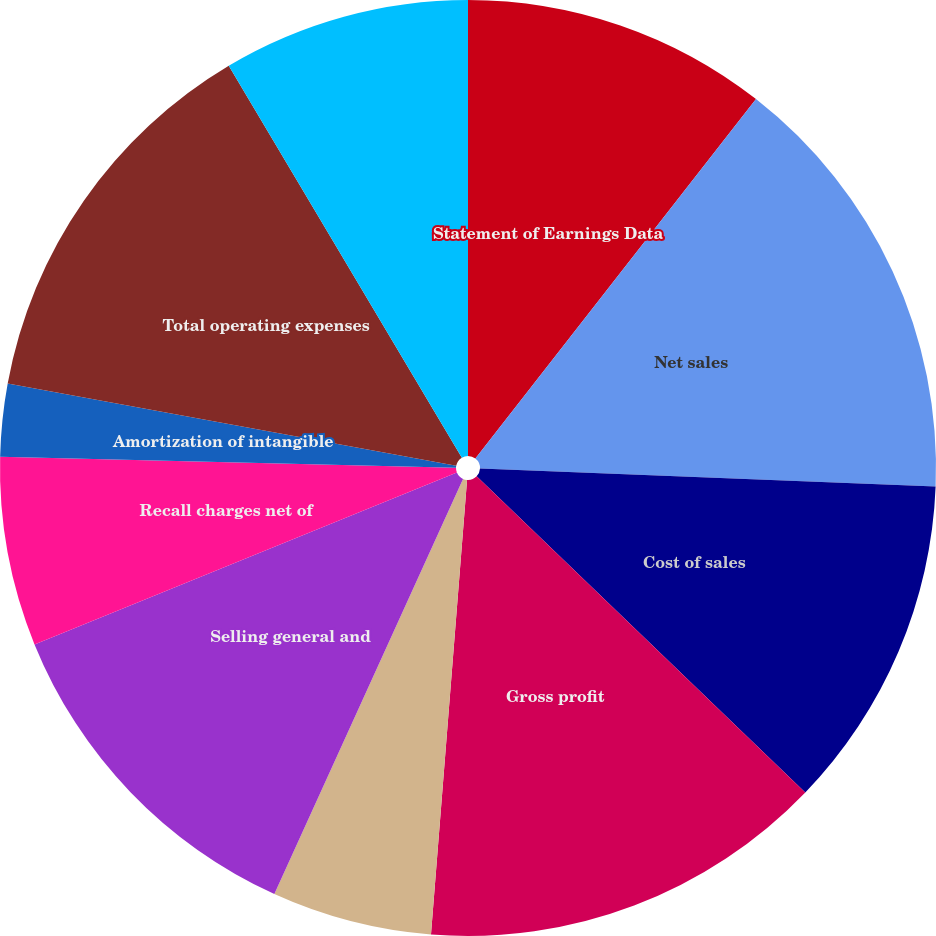<chart> <loc_0><loc_0><loc_500><loc_500><pie_chart><fcel>Statement of Earnings Data<fcel>Net sales<fcel>Cost of sales<fcel>Gross profit<fcel>Research development and<fcel>Selling general and<fcel>Recall charges net of<fcel>Amortization of intangible<fcel>Total operating expenses<fcel>Operating income<nl><fcel>10.55%<fcel>15.08%<fcel>11.56%<fcel>14.07%<fcel>5.53%<fcel>12.06%<fcel>6.53%<fcel>2.51%<fcel>13.57%<fcel>8.54%<nl></chart> 